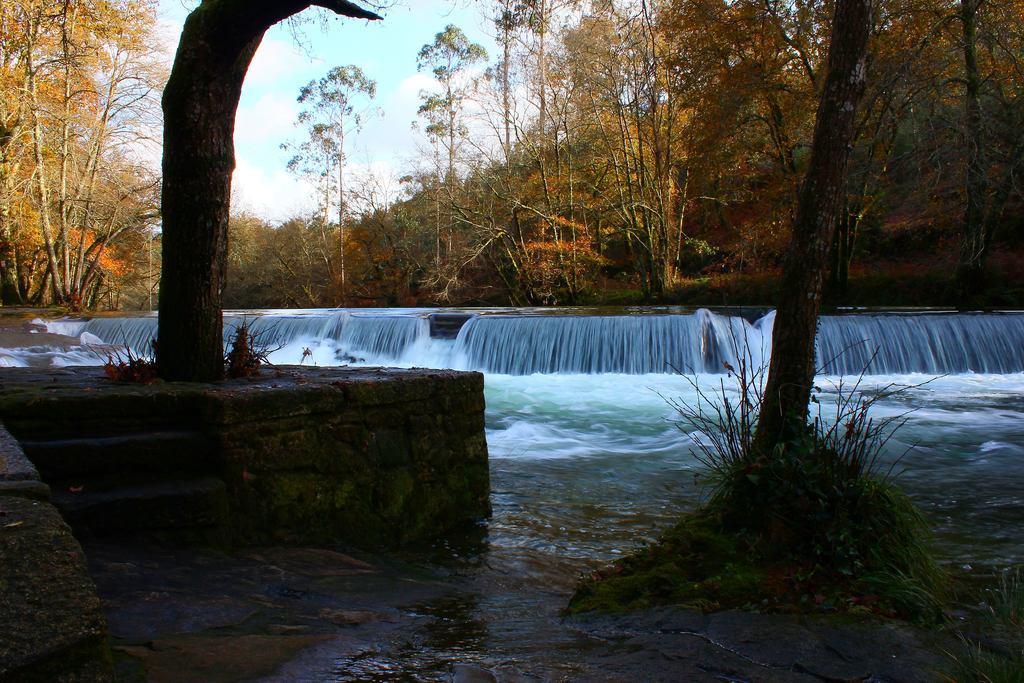Please provide a concise description of this image. In this image we can see the trunk of trees on the left side and the right side as well. Here we can see the waterfall. Here we can see the water. In the background, we can see the trees. 